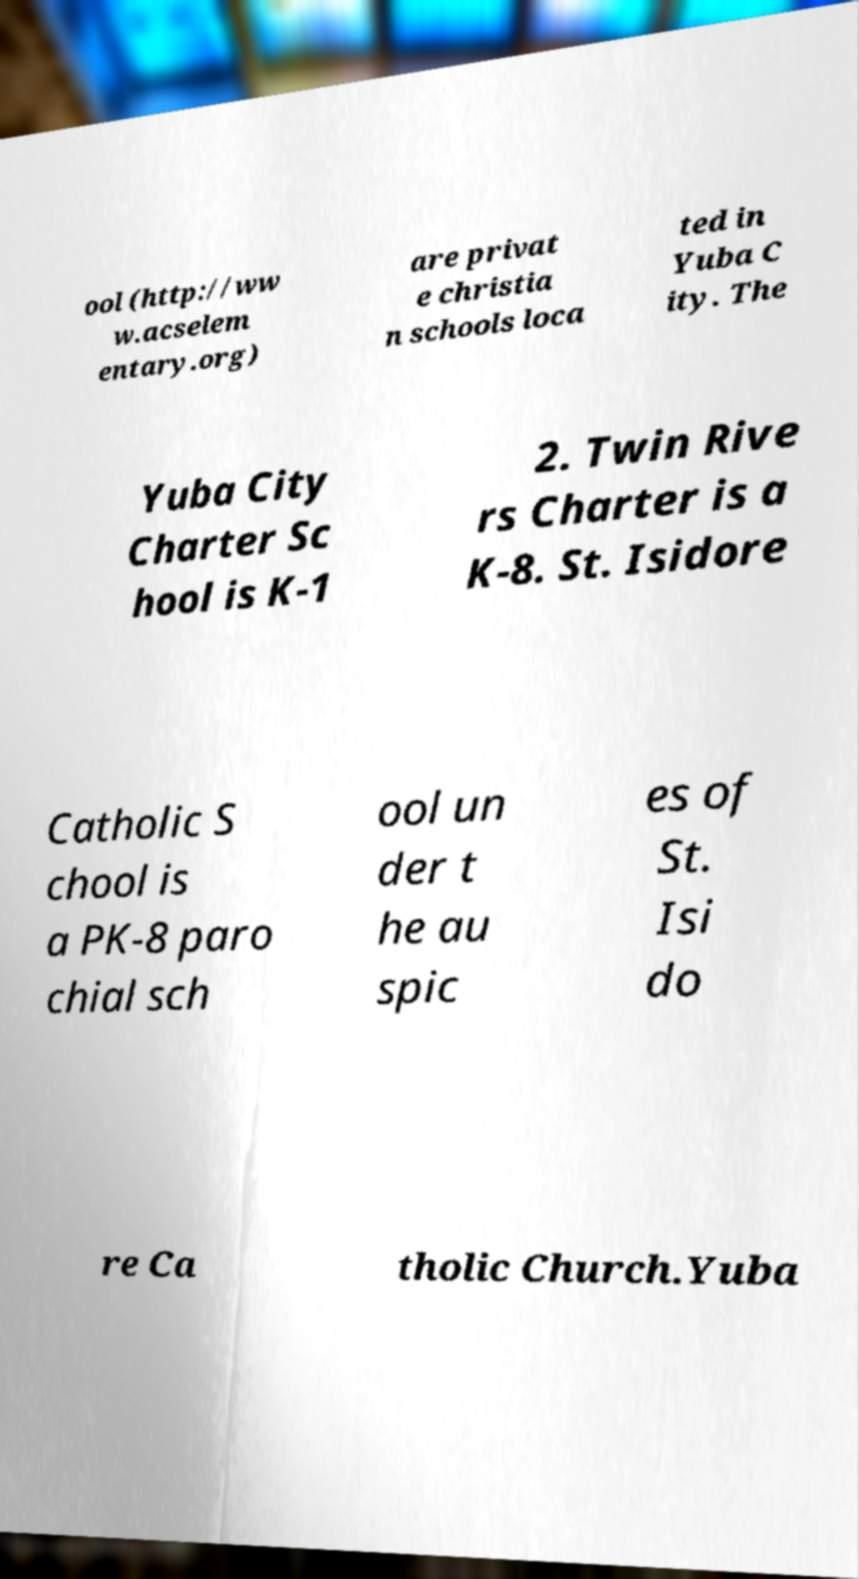Can you accurately transcribe the text from the provided image for me? ool (http://ww w.acselem entary.org) are privat e christia n schools loca ted in Yuba C ity. The Yuba City Charter Sc hool is K-1 2. Twin Rive rs Charter is a K-8. St. Isidore Catholic S chool is a PK-8 paro chial sch ool un der t he au spic es of St. Isi do re Ca tholic Church.Yuba 